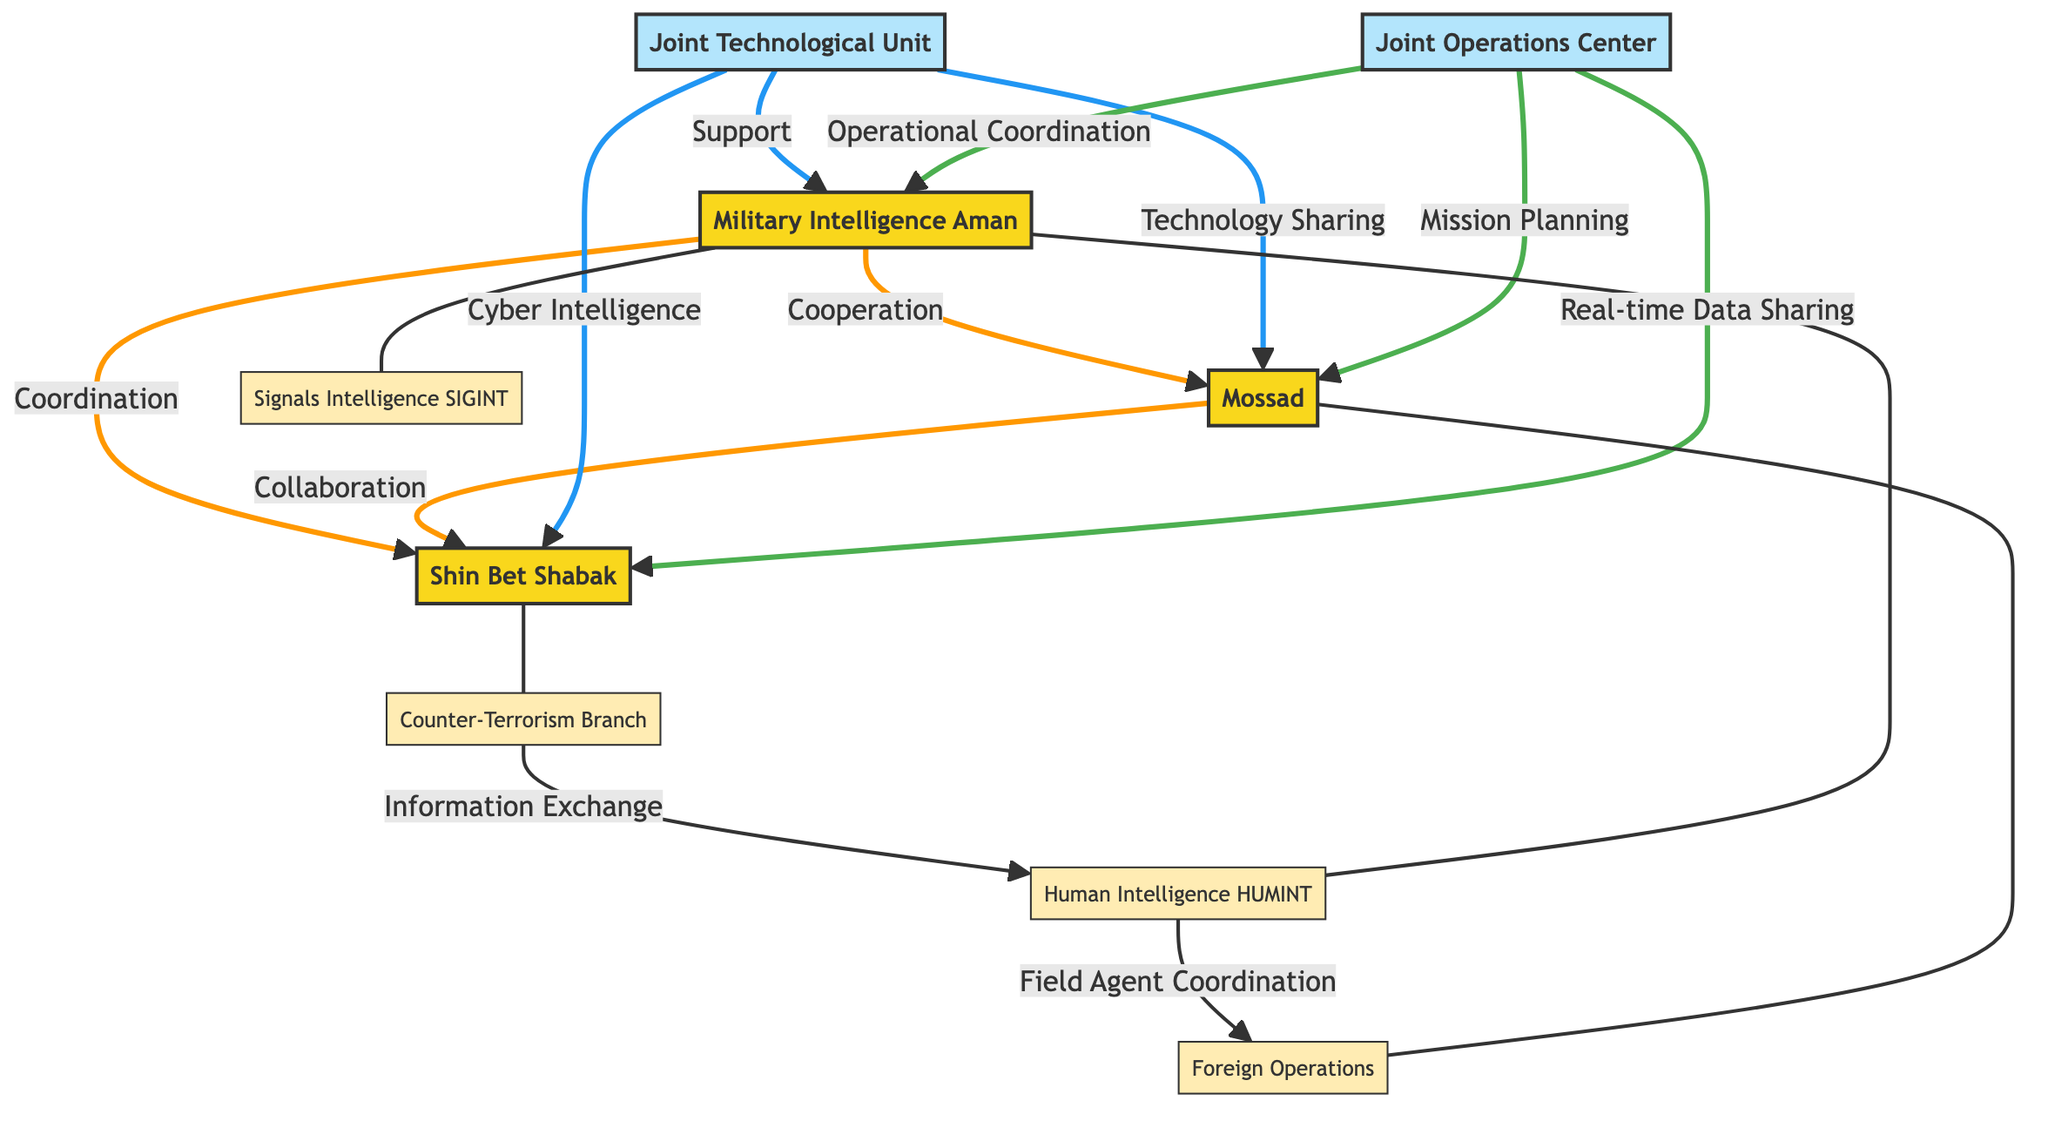What is the total number of nodes in the diagram? The diagram lists the following nodes: Military Intelligence, Mossad, Shin Bet, Joint Technological Unit, Joint Operations Center, Human Intelligence, Signals Intelligence, Counter-Terrorism Branch, and Foreign Operations. Counting these gives a total of 9 nodes.
Answer: 9 What type of intelligence does Military Intelligence focus on? In the diagram, Military Intelligence has two specific types of intelligence represented as sub-nodes: Human Intelligence (HUMINT) and Signals Intelligence (SIGINT). Both are directly connected to Military Intelligence.
Answer: Human Intelligence (HUMINT) and Signals Intelligence (SIGINT) Which entity has a direct collaboration relationship with Shin Bet? The diagram shows that there is a direct edge labeled "Collaboration" between Mossad and Shin Bet. Therefore, this indicates that Mossad collaborates directly with Shin Bet.
Answer: Mossad How many types of support does the Joint Technological Unit provide? The Joint Technological Unit provides support to three entities: Military Intelligence (labeled "Support"), Mossad (labeled "Technology Sharing"), and Shin Bet (labeled "Cyber Intelligence"). This indicates it has three types of support.
Answer: 3 Which unit has a coordination relationship with Military Intelligence? The diagram indicates a direct edge labeled "Coordination" flowing from Shin Bet to Military Intelligence. This denotes that there is a coordination relationship specific to these two nodes.
Answer: Shin Bet What is the primary focus of the Foreign Operations unit? The Foreign Operations unit is primarily concerned with international activities and is shown in the diagram as a sub-node connected to Human Intelligence with the label "Field Agent Coordination", indicating its role in coordinating field agents on foreign missions.
Answer: International activities What is the relationship between the Joint Operations Center and Shin Bet? According to the diagram, the Joint Operations Center has a direct connection to Shin Bet labeled "Real-time Data Sharing", indicating this specific relationship.
Answer: Real-time Data Sharing Which two nodes are parent nodes to their respective intelligence types? The parent nodes are Military Intelligence, which has Human Intelligence and Signals Intelligence as sub-nodes, and Shin Bet, which has the Counter-Terrorism Branch as its sub-node. Therefore, the two parent nodes are Military Intelligence and Shin Bet.
Answer: Military Intelligence and Shin Bet What does the arrow from the Joint Technological Unit to Mossad indicate? The arrow connecting the Joint Technological Unit to Mossad is labeled "Technology Sharing", indicating that the Joint Technological Unit provides technological resources or information to Mossad.
Answer: Technology Sharing 